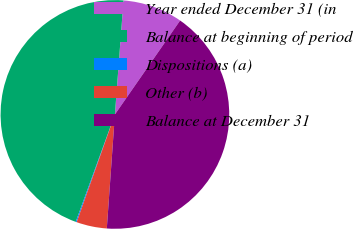Convert chart to OTSL. <chart><loc_0><loc_0><loc_500><loc_500><pie_chart><fcel>Year ended December 31 (in<fcel>Balance at beginning of period<fcel>Dispositions (a)<fcel>Other (b)<fcel>Balance at December 31<nl><fcel>8.46%<fcel>45.63%<fcel>0.14%<fcel>4.3%<fcel>41.47%<nl></chart> 